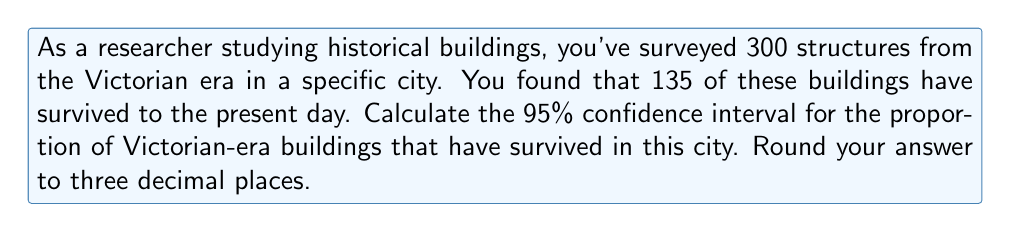Can you answer this question? Let's approach this step-by-step:

1) First, we need to calculate the sample proportion $\hat{p}$:
   $\hat{p} = \frac{\text{number of successes}}{\text{sample size}} = \frac{135}{300} = 0.45$

2) The formula for the confidence interval is:
   $$\hat{p} \pm z_{\alpha/2} \sqrt{\frac{\hat{p}(1-\hat{p})}{n}}$$
   where $z_{\alpha/2}$ is the critical value for the desired confidence level.

3) For a 95% confidence interval, $z_{\alpha/2} = 1.96$

4) Now, let's substitute our values:
   $n = 300$
   $\hat{p} = 0.45$

5) Calculate the standard error:
   $$\sqrt{\frac{\hat{p}(1-\hat{p})}{n}} = \sqrt{\frac{0.45(1-0.45)}{300}} = \sqrt{\frac{0.2475}{300}} = 0.0287$$

6) Now we can calculate the margin of error:
   $1.96 \times 0.0287 = 0.0562$

7) Therefore, our confidence interval is:
   $0.45 \pm 0.0562$

8) This gives us:
   Lower bound: $0.45 - 0.0562 = 0.3938$
   Upper bound: $0.45 + 0.0562 = 0.5062$

9) Rounding to three decimal places:
   $(0.394, 0.506)$
Answer: (0.394, 0.506) 